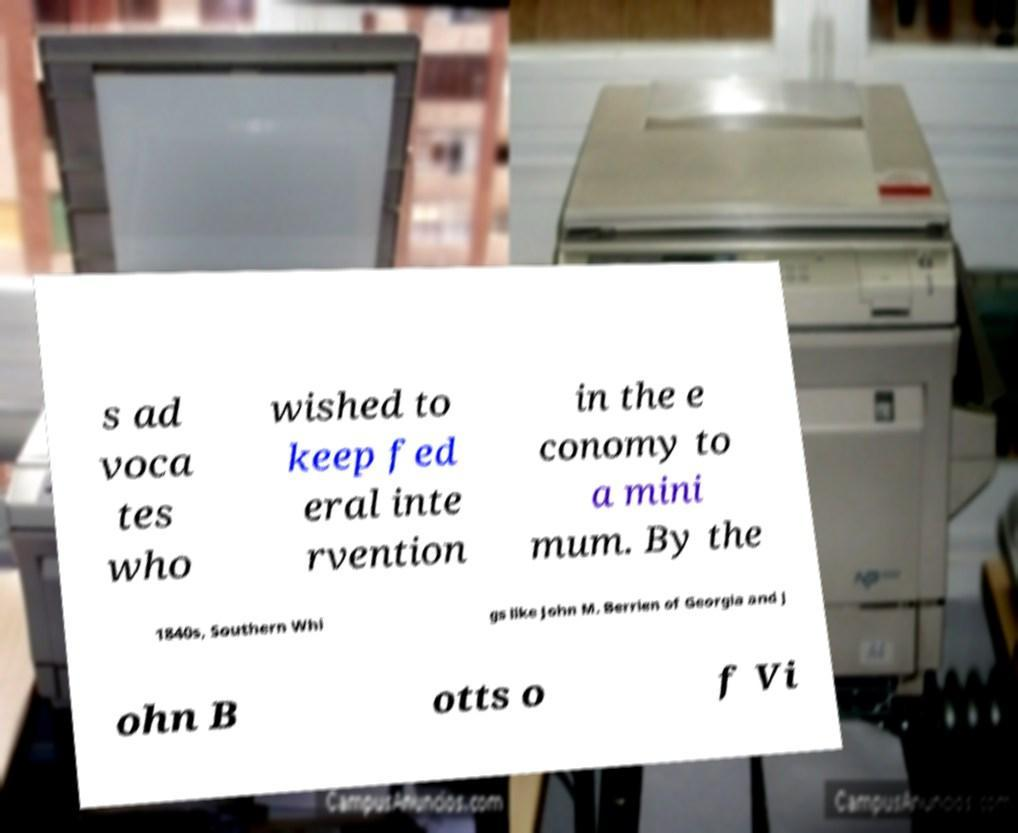Can you accurately transcribe the text from the provided image for me? s ad voca tes who wished to keep fed eral inte rvention in the e conomy to a mini mum. By the 1840s, Southern Whi gs like John M. Berrien of Georgia and J ohn B otts o f Vi 